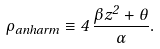<formula> <loc_0><loc_0><loc_500><loc_500>\rho _ { a n h a r m } \equiv 4 \, \frac { \beta z ^ { 2 } + \theta } { \alpha } .</formula> 